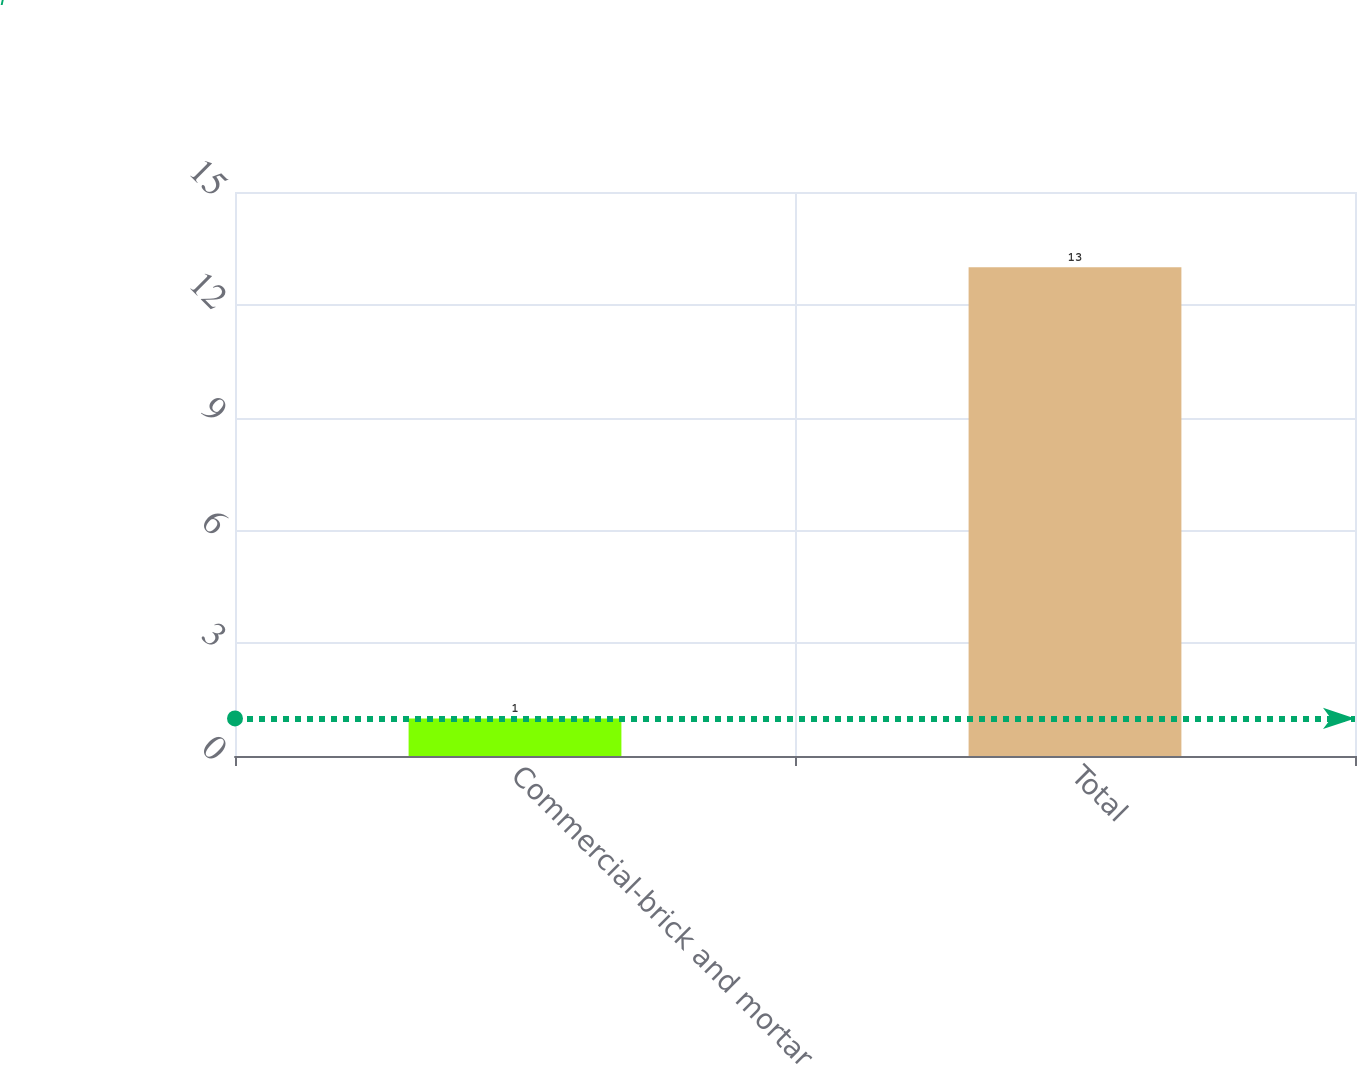Convert chart to OTSL. <chart><loc_0><loc_0><loc_500><loc_500><bar_chart><fcel>Commercial-brick and mortar<fcel>Total<nl><fcel>1<fcel>13<nl></chart> 